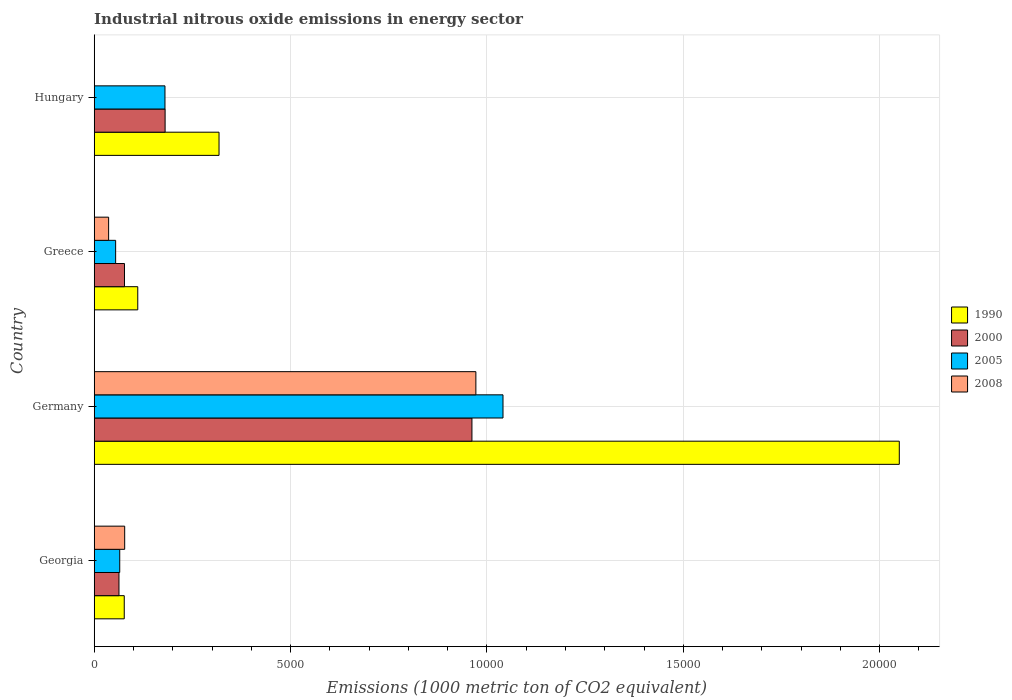How many different coloured bars are there?
Provide a succinct answer. 4. How many groups of bars are there?
Keep it short and to the point. 4. Are the number of bars per tick equal to the number of legend labels?
Keep it short and to the point. Yes. What is the label of the 1st group of bars from the top?
Your answer should be very brief. Hungary. In how many cases, is the number of bars for a given country not equal to the number of legend labels?
Give a very brief answer. 0. What is the amount of industrial nitrous oxide emitted in 2008 in Georgia?
Your answer should be compact. 776.5. Across all countries, what is the maximum amount of industrial nitrous oxide emitted in 2008?
Offer a very short reply. 9718.4. Across all countries, what is the minimum amount of industrial nitrous oxide emitted in 1990?
Keep it short and to the point. 765.3. In which country was the amount of industrial nitrous oxide emitted in 2005 maximum?
Give a very brief answer. Germany. In which country was the amount of industrial nitrous oxide emitted in 1990 minimum?
Ensure brevity in your answer.  Georgia. What is the total amount of industrial nitrous oxide emitted in 2005 in the graph?
Make the answer very short. 1.34e+04. What is the difference between the amount of industrial nitrous oxide emitted in 1990 in Greece and that in Hungary?
Give a very brief answer. -2069.5. What is the difference between the amount of industrial nitrous oxide emitted in 1990 in Georgia and the amount of industrial nitrous oxide emitted in 2008 in Hungary?
Your answer should be very brief. 759.3. What is the average amount of industrial nitrous oxide emitted in 2000 per country?
Your answer should be very brief. 3206.2. What is the difference between the amount of industrial nitrous oxide emitted in 2000 and amount of industrial nitrous oxide emitted in 1990 in Germany?
Provide a succinct answer. -1.09e+04. In how many countries, is the amount of industrial nitrous oxide emitted in 1990 greater than 9000 1000 metric ton?
Give a very brief answer. 1. What is the ratio of the amount of industrial nitrous oxide emitted in 1990 in Germany to that in Greece?
Your answer should be very brief. 18.48. Is the amount of industrial nitrous oxide emitted in 2005 in Germany less than that in Hungary?
Provide a short and direct response. No. What is the difference between the highest and the second highest amount of industrial nitrous oxide emitted in 2008?
Ensure brevity in your answer.  8941.9. What is the difference between the highest and the lowest amount of industrial nitrous oxide emitted in 2000?
Keep it short and to the point. 8987.4. What does the 3rd bar from the bottom in Greece represents?
Keep it short and to the point. 2005. How many bars are there?
Keep it short and to the point. 16. How many countries are there in the graph?
Your answer should be compact. 4. What is the difference between two consecutive major ticks on the X-axis?
Your answer should be compact. 5000. Where does the legend appear in the graph?
Give a very brief answer. Center right. How are the legend labels stacked?
Keep it short and to the point. Vertical. What is the title of the graph?
Ensure brevity in your answer.  Industrial nitrous oxide emissions in energy sector. Does "2007" appear as one of the legend labels in the graph?
Ensure brevity in your answer.  No. What is the label or title of the X-axis?
Give a very brief answer. Emissions (1000 metric ton of CO2 equivalent). What is the label or title of the Y-axis?
Give a very brief answer. Country. What is the Emissions (1000 metric ton of CO2 equivalent) of 1990 in Georgia?
Ensure brevity in your answer.  765.3. What is the Emissions (1000 metric ton of CO2 equivalent) in 2000 in Georgia?
Keep it short and to the point. 630.5. What is the Emissions (1000 metric ton of CO2 equivalent) in 2005 in Georgia?
Make the answer very short. 650.1. What is the Emissions (1000 metric ton of CO2 equivalent) in 2008 in Georgia?
Give a very brief answer. 776.5. What is the Emissions (1000 metric ton of CO2 equivalent) in 1990 in Germany?
Your answer should be compact. 2.05e+04. What is the Emissions (1000 metric ton of CO2 equivalent) of 2000 in Germany?
Your answer should be very brief. 9617.9. What is the Emissions (1000 metric ton of CO2 equivalent) in 2005 in Germany?
Keep it short and to the point. 1.04e+04. What is the Emissions (1000 metric ton of CO2 equivalent) in 2008 in Germany?
Ensure brevity in your answer.  9718.4. What is the Emissions (1000 metric ton of CO2 equivalent) of 1990 in Greece?
Give a very brief answer. 1109.1. What is the Emissions (1000 metric ton of CO2 equivalent) of 2000 in Greece?
Provide a short and direct response. 771. What is the Emissions (1000 metric ton of CO2 equivalent) of 2005 in Greece?
Keep it short and to the point. 545.8. What is the Emissions (1000 metric ton of CO2 equivalent) of 2008 in Greece?
Provide a succinct answer. 367.4. What is the Emissions (1000 metric ton of CO2 equivalent) of 1990 in Hungary?
Offer a terse response. 3178.6. What is the Emissions (1000 metric ton of CO2 equivalent) in 2000 in Hungary?
Provide a succinct answer. 1805.4. What is the Emissions (1000 metric ton of CO2 equivalent) in 2005 in Hungary?
Keep it short and to the point. 1802. Across all countries, what is the maximum Emissions (1000 metric ton of CO2 equivalent) of 1990?
Ensure brevity in your answer.  2.05e+04. Across all countries, what is the maximum Emissions (1000 metric ton of CO2 equivalent) of 2000?
Your response must be concise. 9617.9. Across all countries, what is the maximum Emissions (1000 metric ton of CO2 equivalent) of 2005?
Your answer should be compact. 1.04e+04. Across all countries, what is the maximum Emissions (1000 metric ton of CO2 equivalent) of 2008?
Your answer should be compact. 9718.4. Across all countries, what is the minimum Emissions (1000 metric ton of CO2 equivalent) of 1990?
Your response must be concise. 765.3. Across all countries, what is the minimum Emissions (1000 metric ton of CO2 equivalent) in 2000?
Provide a succinct answer. 630.5. Across all countries, what is the minimum Emissions (1000 metric ton of CO2 equivalent) in 2005?
Give a very brief answer. 545.8. Across all countries, what is the minimum Emissions (1000 metric ton of CO2 equivalent) of 2008?
Provide a short and direct response. 6. What is the total Emissions (1000 metric ton of CO2 equivalent) of 1990 in the graph?
Your response must be concise. 2.56e+04. What is the total Emissions (1000 metric ton of CO2 equivalent) of 2000 in the graph?
Provide a short and direct response. 1.28e+04. What is the total Emissions (1000 metric ton of CO2 equivalent) in 2005 in the graph?
Your answer should be very brief. 1.34e+04. What is the total Emissions (1000 metric ton of CO2 equivalent) in 2008 in the graph?
Ensure brevity in your answer.  1.09e+04. What is the difference between the Emissions (1000 metric ton of CO2 equivalent) in 1990 in Georgia and that in Germany?
Offer a terse response. -1.97e+04. What is the difference between the Emissions (1000 metric ton of CO2 equivalent) of 2000 in Georgia and that in Germany?
Ensure brevity in your answer.  -8987.4. What is the difference between the Emissions (1000 metric ton of CO2 equivalent) of 2005 in Georgia and that in Germany?
Give a very brief answer. -9758.8. What is the difference between the Emissions (1000 metric ton of CO2 equivalent) of 2008 in Georgia and that in Germany?
Offer a very short reply. -8941.9. What is the difference between the Emissions (1000 metric ton of CO2 equivalent) in 1990 in Georgia and that in Greece?
Ensure brevity in your answer.  -343.8. What is the difference between the Emissions (1000 metric ton of CO2 equivalent) of 2000 in Georgia and that in Greece?
Offer a terse response. -140.5. What is the difference between the Emissions (1000 metric ton of CO2 equivalent) in 2005 in Georgia and that in Greece?
Make the answer very short. 104.3. What is the difference between the Emissions (1000 metric ton of CO2 equivalent) in 2008 in Georgia and that in Greece?
Make the answer very short. 409.1. What is the difference between the Emissions (1000 metric ton of CO2 equivalent) of 1990 in Georgia and that in Hungary?
Your response must be concise. -2413.3. What is the difference between the Emissions (1000 metric ton of CO2 equivalent) in 2000 in Georgia and that in Hungary?
Your response must be concise. -1174.9. What is the difference between the Emissions (1000 metric ton of CO2 equivalent) of 2005 in Georgia and that in Hungary?
Make the answer very short. -1151.9. What is the difference between the Emissions (1000 metric ton of CO2 equivalent) in 2008 in Georgia and that in Hungary?
Your answer should be very brief. 770.5. What is the difference between the Emissions (1000 metric ton of CO2 equivalent) of 1990 in Germany and that in Greece?
Make the answer very short. 1.94e+04. What is the difference between the Emissions (1000 metric ton of CO2 equivalent) in 2000 in Germany and that in Greece?
Offer a very short reply. 8846.9. What is the difference between the Emissions (1000 metric ton of CO2 equivalent) in 2005 in Germany and that in Greece?
Your response must be concise. 9863.1. What is the difference between the Emissions (1000 metric ton of CO2 equivalent) of 2008 in Germany and that in Greece?
Your response must be concise. 9351. What is the difference between the Emissions (1000 metric ton of CO2 equivalent) of 1990 in Germany and that in Hungary?
Your answer should be very brief. 1.73e+04. What is the difference between the Emissions (1000 metric ton of CO2 equivalent) of 2000 in Germany and that in Hungary?
Give a very brief answer. 7812.5. What is the difference between the Emissions (1000 metric ton of CO2 equivalent) of 2005 in Germany and that in Hungary?
Your answer should be compact. 8606.9. What is the difference between the Emissions (1000 metric ton of CO2 equivalent) of 2008 in Germany and that in Hungary?
Offer a terse response. 9712.4. What is the difference between the Emissions (1000 metric ton of CO2 equivalent) of 1990 in Greece and that in Hungary?
Ensure brevity in your answer.  -2069.5. What is the difference between the Emissions (1000 metric ton of CO2 equivalent) of 2000 in Greece and that in Hungary?
Make the answer very short. -1034.4. What is the difference between the Emissions (1000 metric ton of CO2 equivalent) in 2005 in Greece and that in Hungary?
Offer a terse response. -1256.2. What is the difference between the Emissions (1000 metric ton of CO2 equivalent) in 2008 in Greece and that in Hungary?
Offer a very short reply. 361.4. What is the difference between the Emissions (1000 metric ton of CO2 equivalent) of 1990 in Georgia and the Emissions (1000 metric ton of CO2 equivalent) of 2000 in Germany?
Your answer should be very brief. -8852.6. What is the difference between the Emissions (1000 metric ton of CO2 equivalent) of 1990 in Georgia and the Emissions (1000 metric ton of CO2 equivalent) of 2005 in Germany?
Make the answer very short. -9643.6. What is the difference between the Emissions (1000 metric ton of CO2 equivalent) of 1990 in Georgia and the Emissions (1000 metric ton of CO2 equivalent) of 2008 in Germany?
Offer a very short reply. -8953.1. What is the difference between the Emissions (1000 metric ton of CO2 equivalent) in 2000 in Georgia and the Emissions (1000 metric ton of CO2 equivalent) in 2005 in Germany?
Provide a succinct answer. -9778.4. What is the difference between the Emissions (1000 metric ton of CO2 equivalent) of 2000 in Georgia and the Emissions (1000 metric ton of CO2 equivalent) of 2008 in Germany?
Keep it short and to the point. -9087.9. What is the difference between the Emissions (1000 metric ton of CO2 equivalent) in 2005 in Georgia and the Emissions (1000 metric ton of CO2 equivalent) in 2008 in Germany?
Offer a terse response. -9068.3. What is the difference between the Emissions (1000 metric ton of CO2 equivalent) of 1990 in Georgia and the Emissions (1000 metric ton of CO2 equivalent) of 2005 in Greece?
Keep it short and to the point. 219.5. What is the difference between the Emissions (1000 metric ton of CO2 equivalent) of 1990 in Georgia and the Emissions (1000 metric ton of CO2 equivalent) of 2008 in Greece?
Give a very brief answer. 397.9. What is the difference between the Emissions (1000 metric ton of CO2 equivalent) of 2000 in Georgia and the Emissions (1000 metric ton of CO2 equivalent) of 2005 in Greece?
Your response must be concise. 84.7. What is the difference between the Emissions (1000 metric ton of CO2 equivalent) of 2000 in Georgia and the Emissions (1000 metric ton of CO2 equivalent) of 2008 in Greece?
Your answer should be very brief. 263.1. What is the difference between the Emissions (1000 metric ton of CO2 equivalent) of 2005 in Georgia and the Emissions (1000 metric ton of CO2 equivalent) of 2008 in Greece?
Keep it short and to the point. 282.7. What is the difference between the Emissions (1000 metric ton of CO2 equivalent) of 1990 in Georgia and the Emissions (1000 metric ton of CO2 equivalent) of 2000 in Hungary?
Make the answer very short. -1040.1. What is the difference between the Emissions (1000 metric ton of CO2 equivalent) of 1990 in Georgia and the Emissions (1000 metric ton of CO2 equivalent) of 2005 in Hungary?
Offer a terse response. -1036.7. What is the difference between the Emissions (1000 metric ton of CO2 equivalent) in 1990 in Georgia and the Emissions (1000 metric ton of CO2 equivalent) in 2008 in Hungary?
Keep it short and to the point. 759.3. What is the difference between the Emissions (1000 metric ton of CO2 equivalent) of 2000 in Georgia and the Emissions (1000 metric ton of CO2 equivalent) of 2005 in Hungary?
Ensure brevity in your answer.  -1171.5. What is the difference between the Emissions (1000 metric ton of CO2 equivalent) in 2000 in Georgia and the Emissions (1000 metric ton of CO2 equivalent) in 2008 in Hungary?
Give a very brief answer. 624.5. What is the difference between the Emissions (1000 metric ton of CO2 equivalent) in 2005 in Georgia and the Emissions (1000 metric ton of CO2 equivalent) in 2008 in Hungary?
Ensure brevity in your answer.  644.1. What is the difference between the Emissions (1000 metric ton of CO2 equivalent) in 1990 in Germany and the Emissions (1000 metric ton of CO2 equivalent) in 2000 in Greece?
Your answer should be very brief. 1.97e+04. What is the difference between the Emissions (1000 metric ton of CO2 equivalent) in 1990 in Germany and the Emissions (1000 metric ton of CO2 equivalent) in 2005 in Greece?
Your response must be concise. 2.00e+04. What is the difference between the Emissions (1000 metric ton of CO2 equivalent) of 1990 in Germany and the Emissions (1000 metric ton of CO2 equivalent) of 2008 in Greece?
Your answer should be compact. 2.01e+04. What is the difference between the Emissions (1000 metric ton of CO2 equivalent) of 2000 in Germany and the Emissions (1000 metric ton of CO2 equivalent) of 2005 in Greece?
Offer a very short reply. 9072.1. What is the difference between the Emissions (1000 metric ton of CO2 equivalent) of 2000 in Germany and the Emissions (1000 metric ton of CO2 equivalent) of 2008 in Greece?
Your response must be concise. 9250.5. What is the difference between the Emissions (1000 metric ton of CO2 equivalent) of 2005 in Germany and the Emissions (1000 metric ton of CO2 equivalent) of 2008 in Greece?
Offer a very short reply. 1.00e+04. What is the difference between the Emissions (1000 metric ton of CO2 equivalent) of 1990 in Germany and the Emissions (1000 metric ton of CO2 equivalent) of 2000 in Hungary?
Make the answer very short. 1.87e+04. What is the difference between the Emissions (1000 metric ton of CO2 equivalent) in 1990 in Germany and the Emissions (1000 metric ton of CO2 equivalent) in 2005 in Hungary?
Your answer should be very brief. 1.87e+04. What is the difference between the Emissions (1000 metric ton of CO2 equivalent) of 1990 in Germany and the Emissions (1000 metric ton of CO2 equivalent) of 2008 in Hungary?
Offer a very short reply. 2.05e+04. What is the difference between the Emissions (1000 metric ton of CO2 equivalent) in 2000 in Germany and the Emissions (1000 metric ton of CO2 equivalent) in 2005 in Hungary?
Give a very brief answer. 7815.9. What is the difference between the Emissions (1000 metric ton of CO2 equivalent) in 2000 in Germany and the Emissions (1000 metric ton of CO2 equivalent) in 2008 in Hungary?
Your answer should be compact. 9611.9. What is the difference between the Emissions (1000 metric ton of CO2 equivalent) of 2005 in Germany and the Emissions (1000 metric ton of CO2 equivalent) of 2008 in Hungary?
Ensure brevity in your answer.  1.04e+04. What is the difference between the Emissions (1000 metric ton of CO2 equivalent) in 1990 in Greece and the Emissions (1000 metric ton of CO2 equivalent) in 2000 in Hungary?
Your answer should be compact. -696.3. What is the difference between the Emissions (1000 metric ton of CO2 equivalent) in 1990 in Greece and the Emissions (1000 metric ton of CO2 equivalent) in 2005 in Hungary?
Your answer should be very brief. -692.9. What is the difference between the Emissions (1000 metric ton of CO2 equivalent) of 1990 in Greece and the Emissions (1000 metric ton of CO2 equivalent) of 2008 in Hungary?
Your answer should be very brief. 1103.1. What is the difference between the Emissions (1000 metric ton of CO2 equivalent) in 2000 in Greece and the Emissions (1000 metric ton of CO2 equivalent) in 2005 in Hungary?
Offer a terse response. -1031. What is the difference between the Emissions (1000 metric ton of CO2 equivalent) of 2000 in Greece and the Emissions (1000 metric ton of CO2 equivalent) of 2008 in Hungary?
Provide a succinct answer. 765. What is the difference between the Emissions (1000 metric ton of CO2 equivalent) of 2005 in Greece and the Emissions (1000 metric ton of CO2 equivalent) of 2008 in Hungary?
Make the answer very short. 539.8. What is the average Emissions (1000 metric ton of CO2 equivalent) in 1990 per country?
Keep it short and to the point. 6388.15. What is the average Emissions (1000 metric ton of CO2 equivalent) in 2000 per country?
Ensure brevity in your answer.  3206.2. What is the average Emissions (1000 metric ton of CO2 equivalent) of 2005 per country?
Make the answer very short. 3351.7. What is the average Emissions (1000 metric ton of CO2 equivalent) of 2008 per country?
Provide a short and direct response. 2717.07. What is the difference between the Emissions (1000 metric ton of CO2 equivalent) in 1990 and Emissions (1000 metric ton of CO2 equivalent) in 2000 in Georgia?
Keep it short and to the point. 134.8. What is the difference between the Emissions (1000 metric ton of CO2 equivalent) in 1990 and Emissions (1000 metric ton of CO2 equivalent) in 2005 in Georgia?
Provide a succinct answer. 115.2. What is the difference between the Emissions (1000 metric ton of CO2 equivalent) of 1990 and Emissions (1000 metric ton of CO2 equivalent) of 2008 in Georgia?
Ensure brevity in your answer.  -11.2. What is the difference between the Emissions (1000 metric ton of CO2 equivalent) of 2000 and Emissions (1000 metric ton of CO2 equivalent) of 2005 in Georgia?
Offer a very short reply. -19.6. What is the difference between the Emissions (1000 metric ton of CO2 equivalent) of 2000 and Emissions (1000 metric ton of CO2 equivalent) of 2008 in Georgia?
Your answer should be compact. -146. What is the difference between the Emissions (1000 metric ton of CO2 equivalent) of 2005 and Emissions (1000 metric ton of CO2 equivalent) of 2008 in Georgia?
Your answer should be compact. -126.4. What is the difference between the Emissions (1000 metric ton of CO2 equivalent) in 1990 and Emissions (1000 metric ton of CO2 equivalent) in 2000 in Germany?
Ensure brevity in your answer.  1.09e+04. What is the difference between the Emissions (1000 metric ton of CO2 equivalent) of 1990 and Emissions (1000 metric ton of CO2 equivalent) of 2005 in Germany?
Provide a short and direct response. 1.01e+04. What is the difference between the Emissions (1000 metric ton of CO2 equivalent) in 1990 and Emissions (1000 metric ton of CO2 equivalent) in 2008 in Germany?
Ensure brevity in your answer.  1.08e+04. What is the difference between the Emissions (1000 metric ton of CO2 equivalent) of 2000 and Emissions (1000 metric ton of CO2 equivalent) of 2005 in Germany?
Keep it short and to the point. -791. What is the difference between the Emissions (1000 metric ton of CO2 equivalent) in 2000 and Emissions (1000 metric ton of CO2 equivalent) in 2008 in Germany?
Offer a terse response. -100.5. What is the difference between the Emissions (1000 metric ton of CO2 equivalent) of 2005 and Emissions (1000 metric ton of CO2 equivalent) of 2008 in Germany?
Make the answer very short. 690.5. What is the difference between the Emissions (1000 metric ton of CO2 equivalent) of 1990 and Emissions (1000 metric ton of CO2 equivalent) of 2000 in Greece?
Give a very brief answer. 338.1. What is the difference between the Emissions (1000 metric ton of CO2 equivalent) of 1990 and Emissions (1000 metric ton of CO2 equivalent) of 2005 in Greece?
Provide a short and direct response. 563.3. What is the difference between the Emissions (1000 metric ton of CO2 equivalent) of 1990 and Emissions (1000 metric ton of CO2 equivalent) of 2008 in Greece?
Offer a terse response. 741.7. What is the difference between the Emissions (1000 metric ton of CO2 equivalent) in 2000 and Emissions (1000 metric ton of CO2 equivalent) in 2005 in Greece?
Give a very brief answer. 225.2. What is the difference between the Emissions (1000 metric ton of CO2 equivalent) in 2000 and Emissions (1000 metric ton of CO2 equivalent) in 2008 in Greece?
Offer a terse response. 403.6. What is the difference between the Emissions (1000 metric ton of CO2 equivalent) of 2005 and Emissions (1000 metric ton of CO2 equivalent) of 2008 in Greece?
Your answer should be compact. 178.4. What is the difference between the Emissions (1000 metric ton of CO2 equivalent) in 1990 and Emissions (1000 metric ton of CO2 equivalent) in 2000 in Hungary?
Offer a terse response. 1373.2. What is the difference between the Emissions (1000 metric ton of CO2 equivalent) of 1990 and Emissions (1000 metric ton of CO2 equivalent) of 2005 in Hungary?
Ensure brevity in your answer.  1376.6. What is the difference between the Emissions (1000 metric ton of CO2 equivalent) of 1990 and Emissions (1000 metric ton of CO2 equivalent) of 2008 in Hungary?
Offer a very short reply. 3172.6. What is the difference between the Emissions (1000 metric ton of CO2 equivalent) of 2000 and Emissions (1000 metric ton of CO2 equivalent) of 2005 in Hungary?
Your answer should be compact. 3.4. What is the difference between the Emissions (1000 metric ton of CO2 equivalent) in 2000 and Emissions (1000 metric ton of CO2 equivalent) in 2008 in Hungary?
Provide a short and direct response. 1799.4. What is the difference between the Emissions (1000 metric ton of CO2 equivalent) in 2005 and Emissions (1000 metric ton of CO2 equivalent) in 2008 in Hungary?
Your response must be concise. 1796. What is the ratio of the Emissions (1000 metric ton of CO2 equivalent) in 1990 in Georgia to that in Germany?
Your answer should be compact. 0.04. What is the ratio of the Emissions (1000 metric ton of CO2 equivalent) in 2000 in Georgia to that in Germany?
Make the answer very short. 0.07. What is the ratio of the Emissions (1000 metric ton of CO2 equivalent) of 2005 in Georgia to that in Germany?
Give a very brief answer. 0.06. What is the ratio of the Emissions (1000 metric ton of CO2 equivalent) of 2008 in Georgia to that in Germany?
Provide a succinct answer. 0.08. What is the ratio of the Emissions (1000 metric ton of CO2 equivalent) of 1990 in Georgia to that in Greece?
Your answer should be compact. 0.69. What is the ratio of the Emissions (1000 metric ton of CO2 equivalent) of 2000 in Georgia to that in Greece?
Your response must be concise. 0.82. What is the ratio of the Emissions (1000 metric ton of CO2 equivalent) in 2005 in Georgia to that in Greece?
Give a very brief answer. 1.19. What is the ratio of the Emissions (1000 metric ton of CO2 equivalent) of 2008 in Georgia to that in Greece?
Ensure brevity in your answer.  2.11. What is the ratio of the Emissions (1000 metric ton of CO2 equivalent) in 1990 in Georgia to that in Hungary?
Make the answer very short. 0.24. What is the ratio of the Emissions (1000 metric ton of CO2 equivalent) of 2000 in Georgia to that in Hungary?
Provide a short and direct response. 0.35. What is the ratio of the Emissions (1000 metric ton of CO2 equivalent) in 2005 in Georgia to that in Hungary?
Offer a terse response. 0.36. What is the ratio of the Emissions (1000 metric ton of CO2 equivalent) in 2008 in Georgia to that in Hungary?
Offer a terse response. 129.42. What is the ratio of the Emissions (1000 metric ton of CO2 equivalent) in 1990 in Germany to that in Greece?
Ensure brevity in your answer.  18.48. What is the ratio of the Emissions (1000 metric ton of CO2 equivalent) of 2000 in Germany to that in Greece?
Your answer should be very brief. 12.47. What is the ratio of the Emissions (1000 metric ton of CO2 equivalent) of 2005 in Germany to that in Greece?
Offer a very short reply. 19.07. What is the ratio of the Emissions (1000 metric ton of CO2 equivalent) of 2008 in Germany to that in Greece?
Provide a short and direct response. 26.45. What is the ratio of the Emissions (1000 metric ton of CO2 equivalent) in 1990 in Germany to that in Hungary?
Provide a short and direct response. 6.45. What is the ratio of the Emissions (1000 metric ton of CO2 equivalent) of 2000 in Germany to that in Hungary?
Keep it short and to the point. 5.33. What is the ratio of the Emissions (1000 metric ton of CO2 equivalent) in 2005 in Germany to that in Hungary?
Your response must be concise. 5.78. What is the ratio of the Emissions (1000 metric ton of CO2 equivalent) in 2008 in Germany to that in Hungary?
Keep it short and to the point. 1619.73. What is the ratio of the Emissions (1000 metric ton of CO2 equivalent) of 1990 in Greece to that in Hungary?
Your answer should be compact. 0.35. What is the ratio of the Emissions (1000 metric ton of CO2 equivalent) in 2000 in Greece to that in Hungary?
Your response must be concise. 0.43. What is the ratio of the Emissions (1000 metric ton of CO2 equivalent) in 2005 in Greece to that in Hungary?
Provide a short and direct response. 0.3. What is the ratio of the Emissions (1000 metric ton of CO2 equivalent) in 2008 in Greece to that in Hungary?
Your answer should be very brief. 61.23. What is the difference between the highest and the second highest Emissions (1000 metric ton of CO2 equivalent) in 1990?
Ensure brevity in your answer.  1.73e+04. What is the difference between the highest and the second highest Emissions (1000 metric ton of CO2 equivalent) of 2000?
Ensure brevity in your answer.  7812.5. What is the difference between the highest and the second highest Emissions (1000 metric ton of CO2 equivalent) of 2005?
Offer a terse response. 8606.9. What is the difference between the highest and the second highest Emissions (1000 metric ton of CO2 equivalent) in 2008?
Offer a terse response. 8941.9. What is the difference between the highest and the lowest Emissions (1000 metric ton of CO2 equivalent) in 1990?
Your answer should be compact. 1.97e+04. What is the difference between the highest and the lowest Emissions (1000 metric ton of CO2 equivalent) in 2000?
Provide a short and direct response. 8987.4. What is the difference between the highest and the lowest Emissions (1000 metric ton of CO2 equivalent) in 2005?
Ensure brevity in your answer.  9863.1. What is the difference between the highest and the lowest Emissions (1000 metric ton of CO2 equivalent) in 2008?
Provide a short and direct response. 9712.4. 